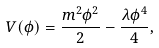Convert formula to latex. <formula><loc_0><loc_0><loc_500><loc_500>V ( \phi ) = \frac { m ^ { 2 } \phi ^ { 2 } } { 2 } - \frac { \lambda \phi ^ { 4 } } { 4 } ,</formula> 